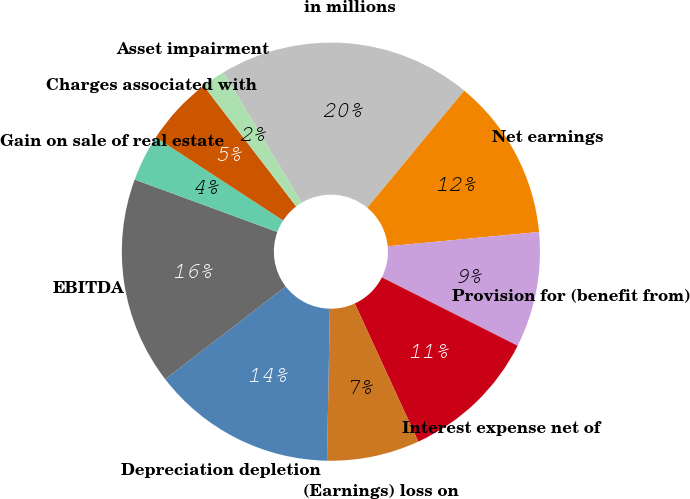<chart> <loc_0><loc_0><loc_500><loc_500><pie_chart><fcel>in millions<fcel>Net earnings<fcel>Provision for (benefit from)<fcel>Interest expense net of<fcel>(Earnings) loss on<fcel>Depreciation depletion<fcel>EBITDA<fcel>Gain on sale of real estate<fcel>Charges associated with<fcel>Asset impairment<nl><fcel>19.6%<fcel>12.49%<fcel>8.93%<fcel>10.71%<fcel>7.16%<fcel>14.27%<fcel>16.04%<fcel>3.6%<fcel>5.38%<fcel>1.82%<nl></chart> 